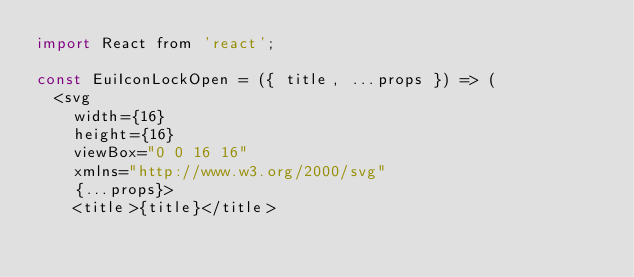Convert code to text. <code><loc_0><loc_0><loc_500><loc_500><_JavaScript_>import React from 'react';

const EuiIconLockOpen = ({ title, ...props }) => (
  <svg
    width={16}
    height={16}
    viewBox="0 0 16 16"
    xmlns="http://www.w3.org/2000/svg"
    {...props}>
    <title>{title}</title></code> 